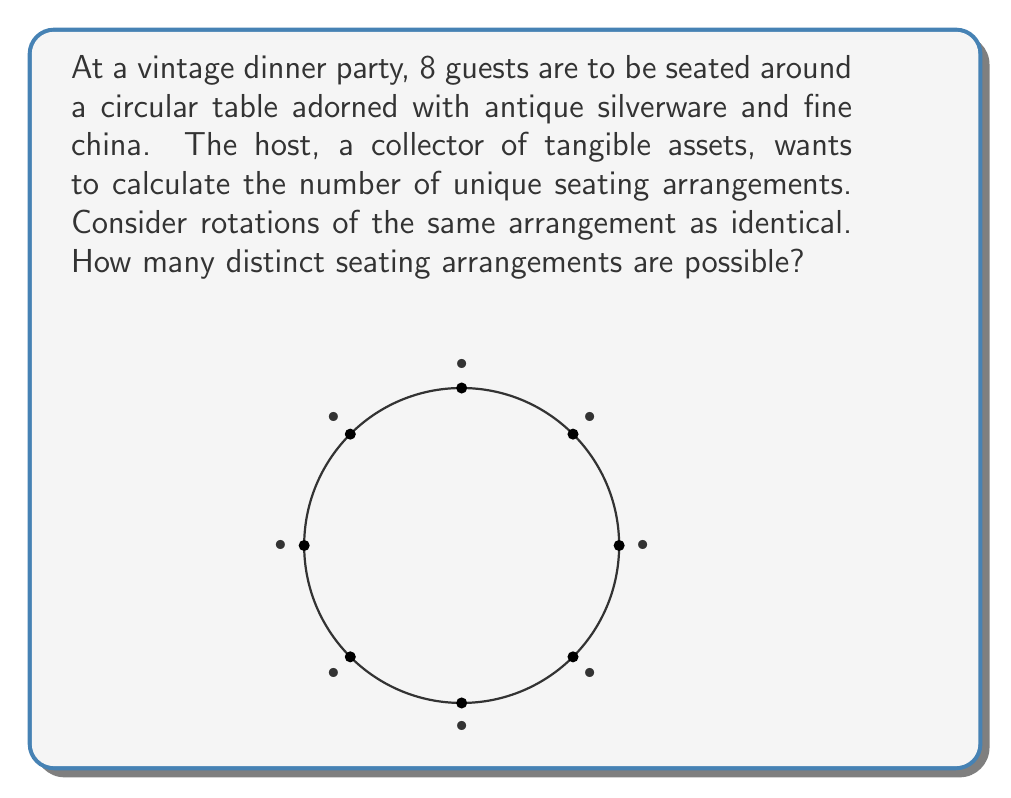Give your solution to this math problem. Let's approach this step-by-step:

1) First, we need to understand that in a circular arrangement, rotations of the same arrangement are considered identical. This means we can fix one person's position.

2) With one person fixed, we now need to arrange the remaining 7 people.

3) This becomes a straightforward permutation problem. We have 7 people to arrange in 7 positions.

4) The number of permutations of n distinct objects is given by n!

5) In this case, we have:

   $$ \text{Number of arrangements} = 7! $$

6) Let's calculate this:
   
   $$ 7! = 7 \times 6 \times 5 \times 4 \times 3 \times 2 \times 1 = 5040 $$

Therefore, there are 5040 distinct seating arrangements possible at this vintage dinner party.
Answer: 5040 